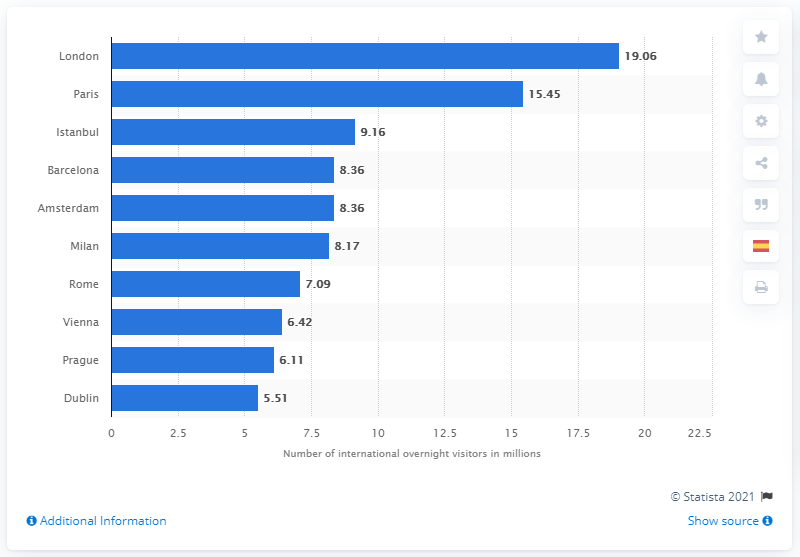List a handful of essential elements in this visual. In 2016, London received 19,060 international overnight visitors. 